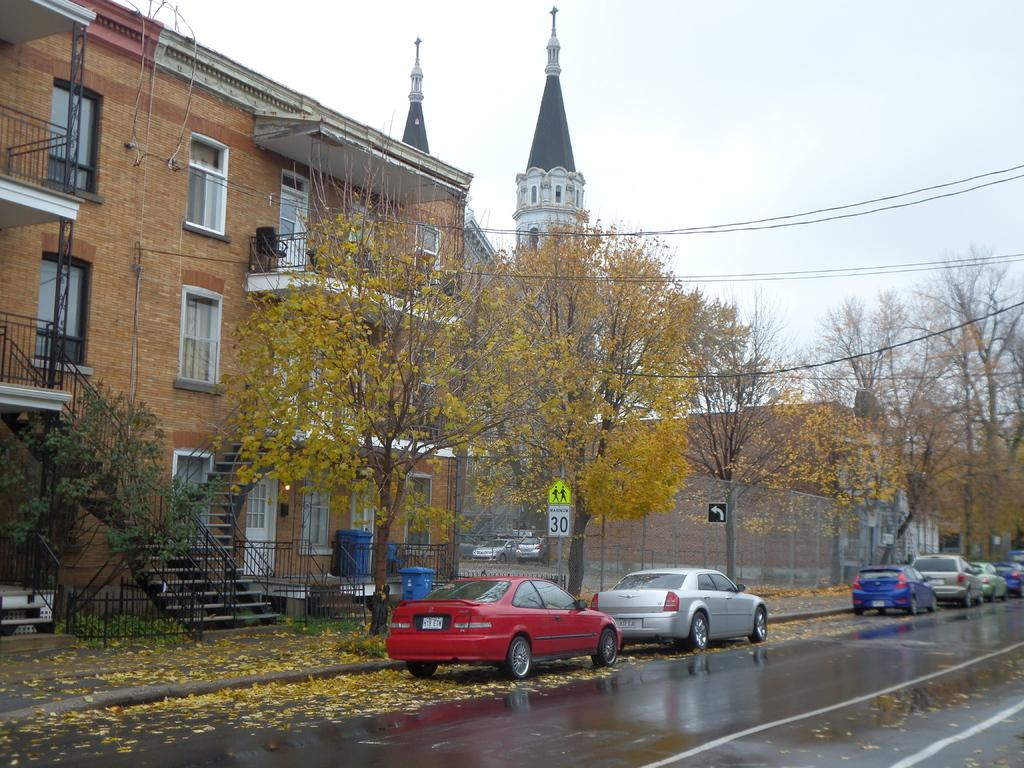What type of structures can be seen in the image? There are buildings in the image. What is located in front of the buildings? There are trees in front of the buildings. What can be seen on the road in the image? There are vehicles on the road. What is visible in the background of the image? The sky is visible in the background of the image. How do the pigs react to the afterthought in the image? There are no pigs or afterthoughts present in the image. 